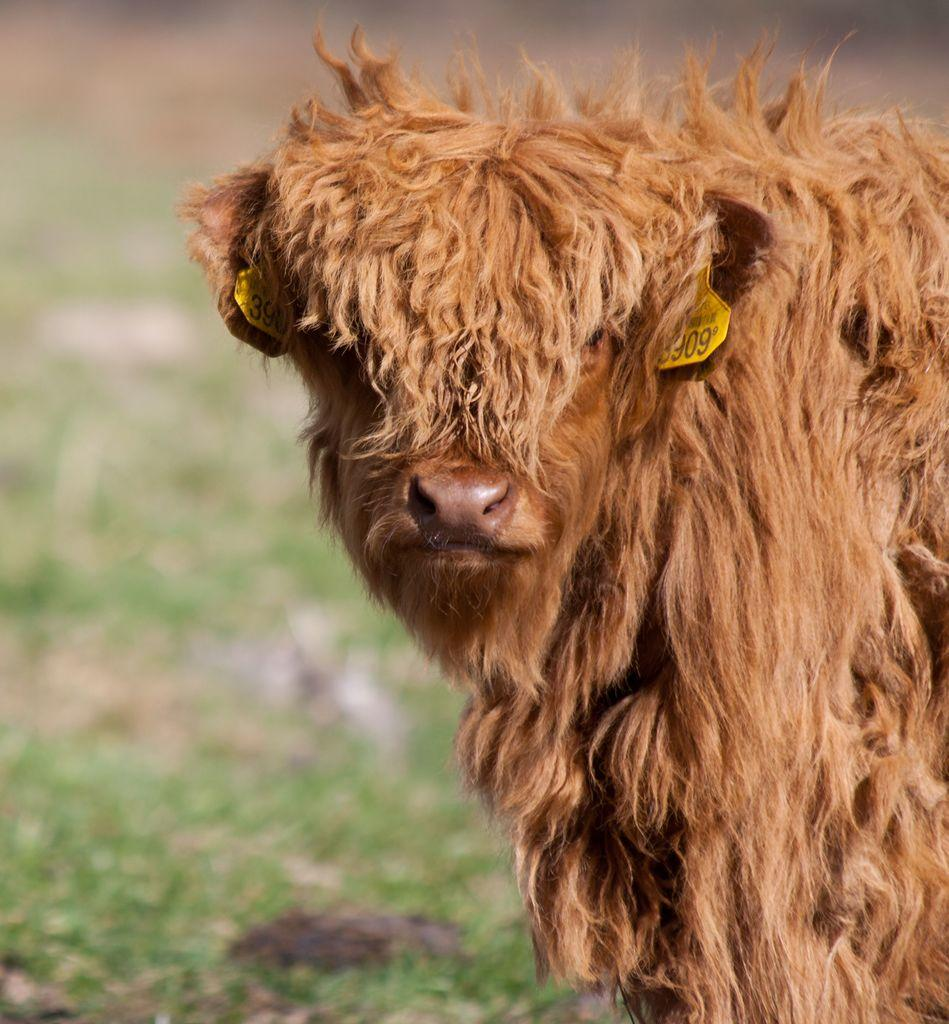What type of animal is on the right side of the image? The specific type of animal cannot be determined from the provided facts. What can be seen in the background of the image? There is grass visible in the background of the image. What type of print is visible on the animal's cap in the image? There is no cap present on the animal in the image, and therefore no print can be observed. 